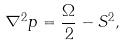Convert formula to latex. <formula><loc_0><loc_0><loc_500><loc_500>\nabla ^ { 2 } p = \frac { \Omega } { 2 } - S ^ { 2 } ,</formula> 